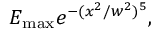<formula> <loc_0><loc_0><loc_500><loc_500>E _ { \max } e ^ { - ( x ^ { 2 } / w ^ { 2 } ) ^ { 5 } } ,</formula> 